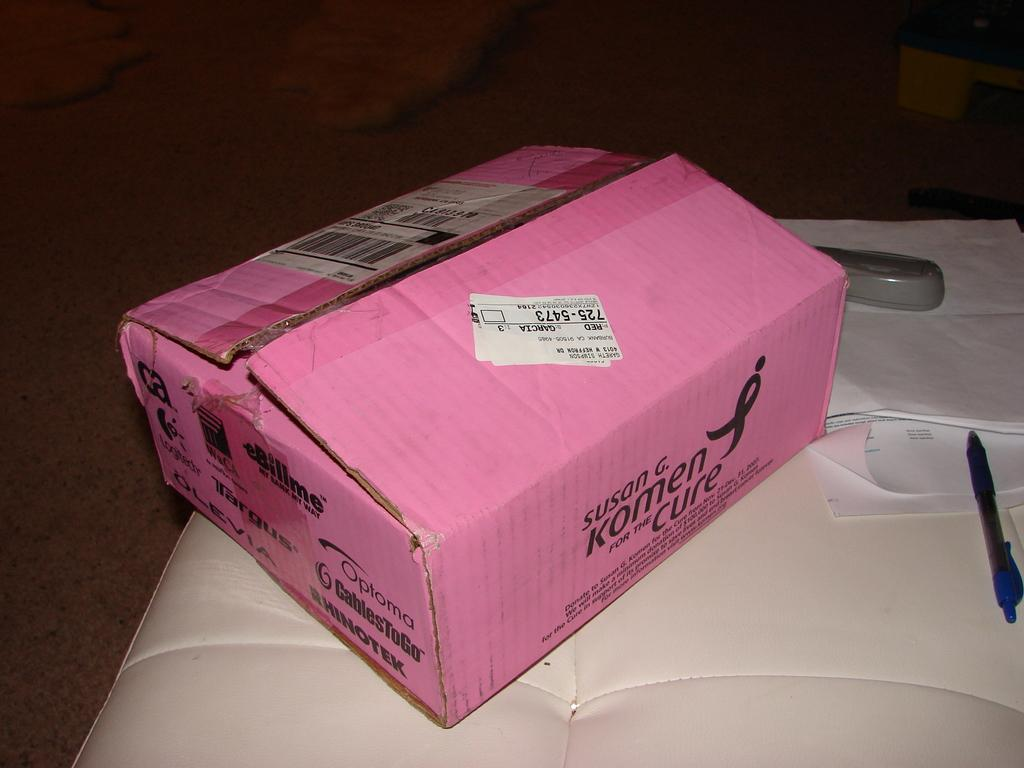<image>
Present a compact description of the photo's key features. A pink opened box for the Susan G. Komen for the Cure laying on top of a white cushion. 